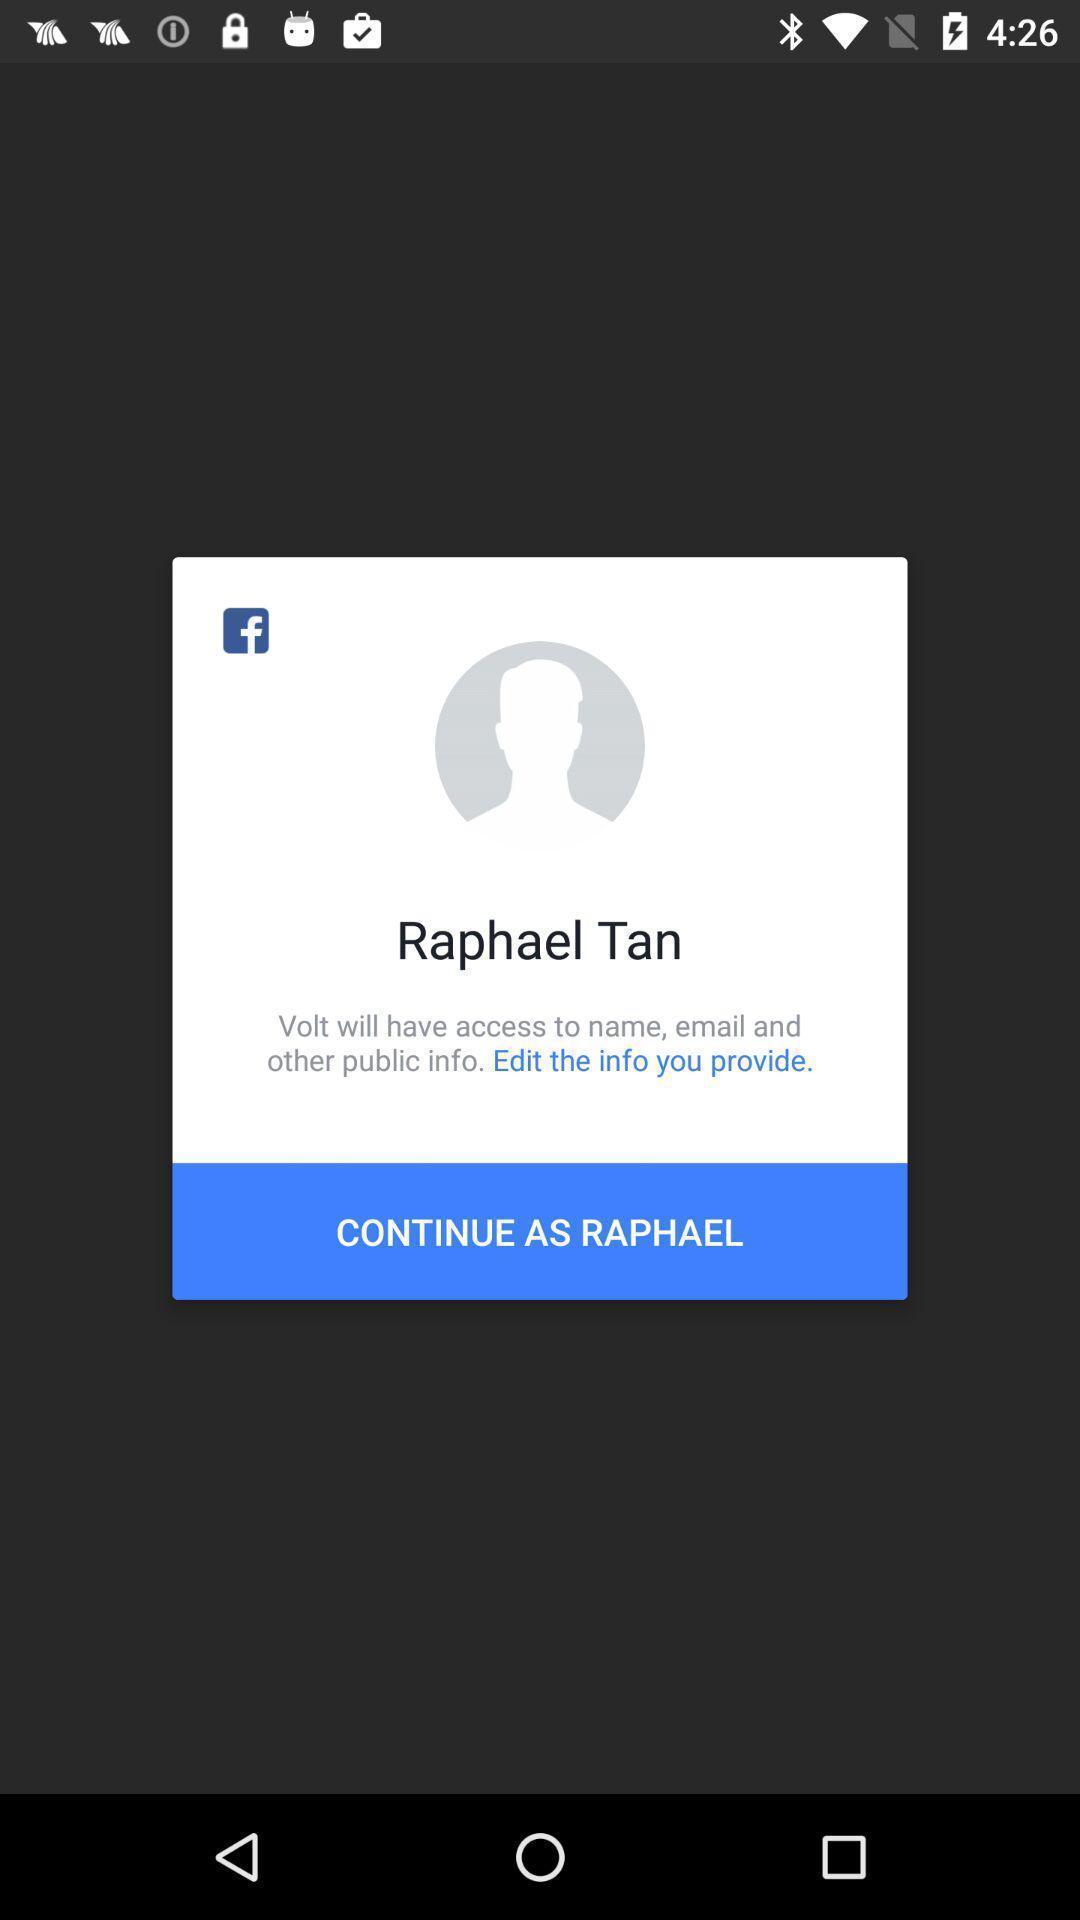Describe the content in this image. Popup to continue in the application. 